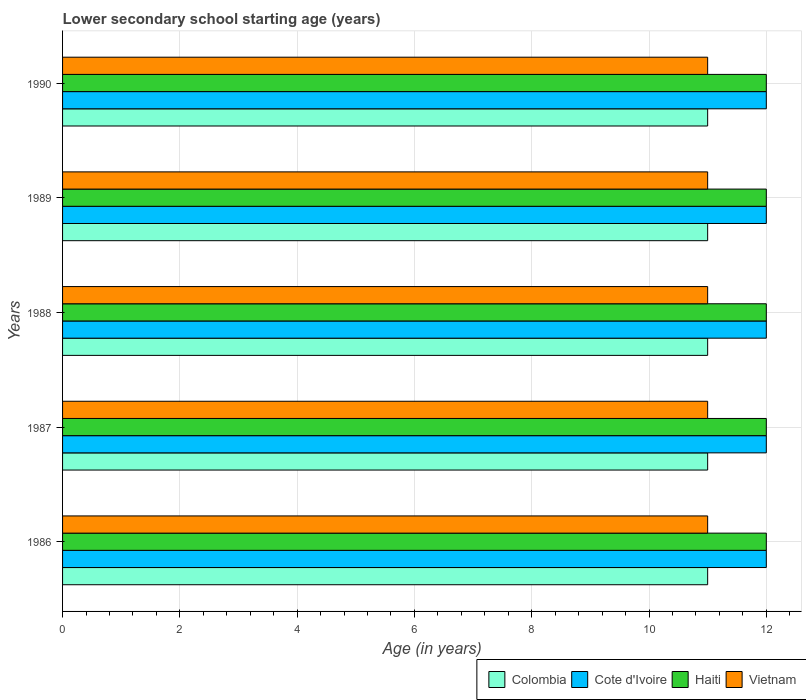How many different coloured bars are there?
Your answer should be compact. 4. How many bars are there on the 3rd tick from the bottom?
Provide a short and direct response. 4. What is the label of the 2nd group of bars from the top?
Make the answer very short. 1989. In how many cases, is the number of bars for a given year not equal to the number of legend labels?
Your response must be concise. 0. What is the lower secondary school starting age of children in Haiti in 1988?
Your response must be concise. 12. Across all years, what is the maximum lower secondary school starting age of children in Colombia?
Provide a succinct answer. 11. Across all years, what is the minimum lower secondary school starting age of children in Haiti?
Your response must be concise. 12. In which year was the lower secondary school starting age of children in Haiti minimum?
Make the answer very short. 1986. What is the total lower secondary school starting age of children in Cote d'Ivoire in the graph?
Offer a terse response. 60. What is the difference between the lower secondary school starting age of children in Cote d'Ivoire in 1990 and the lower secondary school starting age of children in Colombia in 1986?
Provide a short and direct response. 1. In the year 1990, what is the difference between the lower secondary school starting age of children in Cote d'Ivoire and lower secondary school starting age of children in Colombia?
Provide a succinct answer. 1. In how many years, is the lower secondary school starting age of children in Vietnam greater than 4.4 years?
Provide a short and direct response. 5. Is the lower secondary school starting age of children in Haiti in 1986 less than that in 1988?
Your answer should be very brief. No. Is the difference between the lower secondary school starting age of children in Cote d'Ivoire in 1986 and 1990 greater than the difference between the lower secondary school starting age of children in Colombia in 1986 and 1990?
Offer a very short reply. No. What is the difference between the highest and the second highest lower secondary school starting age of children in Cote d'Ivoire?
Ensure brevity in your answer.  0. What is the difference between the highest and the lowest lower secondary school starting age of children in Vietnam?
Offer a terse response. 0. What does the 1st bar from the top in 1990 represents?
Offer a very short reply. Vietnam. What does the 2nd bar from the bottom in 1990 represents?
Offer a very short reply. Cote d'Ivoire. What is the difference between two consecutive major ticks on the X-axis?
Give a very brief answer. 2. Does the graph contain grids?
Make the answer very short. Yes. How many legend labels are there?
Provide a succinct answer. 4. How are the legend labels stacked?
Make the answer very short. Horizontal. What is the title of the graph?
Provide a succinct answer. Lower secondary school starting age (years). What is the label or title of the X-axis?
Give a very brief answer. Age (in years). What is the label or title of the Y-axis?
Provide a short and direct response. Years. What is the Age (in years) of Haiti in 1986?
Provide a succinct answer. 12. What is the Age (in years) in Colombia in 1987?
Offer a terse response. 11. What is the Age (in years) of Cote d'Ivoire in 1987?
Keep it short and to the point. 12. What is the Age (in years) of Vietnam in 1987?
Your answer should be very brief. 11. What is the Age (in years) in Colombia in 1988?
Keep it short and to the point. 11. What is the Age (in years) in Cote d'Ivoire in 1988?
Your answer should be very brief. 12. What is the Age (in years) of Haiti in 1988?
Offer a terse response. 12. What is the Age (in years) of Vietnam in 1988?
Give a very brief answer. 11. What is the Age (in years) of Colombia in 1989?
Make the answer very short. 11. What is the Age (in years) in Cote d'Ivoire in 1989?
Offer a very short reply. 12. What is the Age (in years) in Vietnam in 1989?
Provide a short and direct response. 11. What is the Age (in years) in Cote d'Ivoire in 1990?
Keep it short and to the point. 12. What is the Age (in years) in Vietnam in 1990?
Keep it short and to the point. 11. Across all years, what is the maximum Age (in years) of Colombia?
Provide a succinct answer. 11. Across all years, what is the maximum Age (in years) of Cote d'Ivoire?
Make the answer very short. 12. Across all years, what is the minimum Age (in years) of Colombia?
Offer a very short reply. 11. Across all years, what is the minimum Age (in years) in Cote d'Ivoire?
Keep it short and to the point. 12. Across all years, what is the minimum Age (in years) of Haiti?
Provide a succinct answer. 12. Across all years, what is the minimum Age (in years) of Vietnam?
Keep it short and to the point. 11. What is the total Age (in years) in Colombia in the graph?
Your answer should be very brief. 55. What is the total Age (in years) of Vietnam in the graph?
Make the answer very short. 55. What is the difference between the Age (in years) in Cote d'Ivoire in 1986 and that in 1987?
Offer a terse response. 0. What is the difference between the Age (in years) in Haiti in 1986 and that in 1988?
Give a very brief answer. 0. What is the difference between the Age (in years) in Vietnam in 1986 and that in 1988?
Provide a succinct answer. 0. What is the difference between the Age (in years) in Colombia in 1986 and that in 1989?
Ensure brevity in your answer.  0. What is the difference between the Age (in years) of Cote d'Ivoire in 1986 and that in 1989?
Offer a terse response. 0. What is the difference between the Age (in years) in Colombia in 1986 and that in 1990?
Provide a short and direct response. 0. What is the difference between the Age (in years) of Haiti in 1986 and that in 1990?
Provide a short and direct response. 0. What is the difference between the Age (in years) of Cote d'Ivoire in 1987 and that in 1988?
Offer a terse response. 0. What is the difference between the Age (in years) in Vietnam in 1987 and that in 1988?
Provide a short and direct response. 0. What is the difference between the Age (in years) in Colombia in 1987 and that in 1989?
Give a very brief answer. 0. What is the difference between the Age (in years) of Haiti in 1987 and that in 1990?
Your answer should be compact. 0. What is the difference between the Age (in years) of Haiti in 1988 and that in 1989?
Offer a terse response. 0. What is the difference between the Age (in years) of Colombia in 1988 and that in 1990?
Give a very brief answer. 0. What is the difference between the Age (in years) in Vietnam in 1988 and that in 1990?
Offer a very short reply. 0. What is the difference between the Age (in years) in Vietnam in 1989 and that in 1990?
Keep it short and to the point. 0. What is the difference between the Age (in years) of Colombia in 1986 and the Age (in years) of Cote d'Ivoire in 1987?
Make the answer very short. -1. What is the difference between the Age (in years) of Colombia in 1986 and the Age (in years) of Haiti in 1987?
Make the answer very short. -1. What is the difference between the Age (in years) in Colombia in 1986 and the Age (in years) in Vietnam in 1987?
Make the answer very short. 0. What is the difference between the Age (in years) of Cote d'Ivoire in 1986 and the Age (in years) of Vietnam in 1987?
Offer a very short reply. 1. What is the difference between the Age (in years) of Colombia in 1986 and the Age (in years) of Cote d'Ivoire in 1988?
Your answer should be very brief. -1. What is the difference between the Age (in years) of Colombia in 1986 and the Age (in years) of Vietnam in 1988?
Provide a succinct answer. 0. What is the difference between the Age (in years) of Cote d'Ivoire in 1986 and the Age (in years) of Vietnam in 1988?
Provide a succinct answer. 1. What is the difference between the Age (in years) of Haiti in 1986 and the Age (in years) of Vietnam in 1988?
Provide a short and direct response. 1. What is the difference between the Age (in years) of Colombia in 1986 and the Age (in years) of Haiti in 1989?
Provide a succinct answer. -1. What is the difference between the Age (in years) of Colombia in 1986 and the Age (in years) of Vietnam in 1989?
Give a very brief answer. 0. What is the difference between the Age (in years) of Colombia in 1986 and the Age (in years) of Cote d'Ivoire in 1990?
Your answer should be compact. -1. What is the difference between the Age (in years) in Colombia in 1986 and the Age (in years) in Haiti in 1990?
Provide a succinct answer. -1. What is the difference between the Age (in years) in Haiti in 1986 and the Age (in years) in Vietnam in 1990?
Your answer should be very brief. 1. What is the difference between the Age (in years) of Colombia in 1987 and the Age (in years) of Cote d'Ivoire in 1989?
Your answer should be compact. -1. What is the difference between the Age (in years) of Cote d'Ivoire in 1987 and the Age (in years) of Haiti in 1989?
Offer a terse response. 0. What is the difference between the Age (in years) of Colombia in 1987 and the Age (in years) of Vietnam in 1990?
Give a very brief answer. 0. What is the difference between the Age (in years) in Cote d'Ivoire in 1987 and the Age (in years) in Haiti in 1990?
Provide a short and direct response. 0. What is the difference between the Age (in years) in Colombia in 1988 and the Age (in years) in Cote d'Ivoire in 1989?
Provide a succinct answer. -1. What is the difference between the Age (in years) of Colombia in 1988 and the Age (in years) of Vietnam in 1989?
Offer a very short reply. 0. What is the difference between the Age (in years) of Cote d'Ivoire in 1988 and the Age (in years) of Haiti in 1989?
Make the answer very short. 0. What is the difference between the Age (in years) in Cote d'Ivoire in 1988 and the Age (in years) in Vietnam in 1989?
Provide a succinct answer. 1. What is the difference between the Age (in years) in Haiti in 1988 and the Age (in years) in Vietnam in 1989?
Offer a very short reply. 1. What is the difference between the Age (in years) in Colombia in 1988 and the Age (in years) in Cote d'Ivoire in 1990?
Offer a very short reply. -1. What is the difference between the Age (in years) in Colombia in 1988 and the Age (in years) in Haiti in 1990?
Ensure brevity in your answer.  -1. What is the difference between the Age (in years) of Cote d'Ivoire in 1988 and the Age (in years) of Haiti in 1990?
Your answer should be compact. 0. What is the difference between the Age (in years) in Cote d'Ivoire in 1988 and the Age (in years) in Vietnam in 1990?
Provide a short and direct response. 1. What is the difference between the Age (in years) in Haiti in 1988 and the Age (in years) in Vietnam in 1990?
Offer a very short reply. 1. What is the difference between the Age (in years) in Colombia in 1989 and the Age (in years) in Cote d'Ivoire in 1990?
Give a very brief answer. -1. What is the difference between the Age (in years) in Colombia in 1989 and the Age (in years) in Vietnam in 1990?
Your answer should be very brief. 0. What is the difference between the Age (in years) in Cote d'Ivoire in 1989 and the Age (in years) in Vietnam in 1990?
Offer a terse response. 1. What is the difference between the Age (in years) in Haiti in 1989 and the Age (in years) in Vietnam in 1990?
Your answer should be very brief. 1. What is the average Age (in years) of Cote d'Ivoire per year?
Provide a short and direct response. 12. What is the average Age (in years) of Haiti per year?
Make the answer very short. 12. In the year 1986, what is the difference between the Age (in years) in Colombia and Age (in years) in Haiti?
Give a very brief answer. -1. In the year 1986, what is the difference between the Age (in years) of Colombia and Age (in years) of Vietnam?
Your response must be concise. 0. In the year 1987, what is the difference between the Age (in years) of Colombia and Age (in years) of Haiti?
Keep it short and to the point. -1. In the year 1987, what is the difference between the Age (in years) of Colombia and Age (in years) of Vietnam?
Provide a succinct answer. 0. In the year 1987, what is the difference between the Age (in years) of Haiti and Age (in years) of Vietnam?
Provide a short and direct response. 1. In the year 1988, what is the difference between the Age (in years) in Cote d'Ivoire and Age (in years) in Vietnam?
Provide a succinct answer. 1. In the year 1989, what is the difference between the Age (in years) in Colombia and Age (in years) in Cote d'Ivoire?
Offer a terse response. -1. In the year 1989, what is the difference between the Age (in years) of Colombia and Age (in years) of Haiti?
Ensure brevity in your answer.  -1. In the year 1989, what is the difference between the Age (in years) in Cote d'Ivoire and Age (in years) in Haiti?
Give a very brief answer. 0. In the year 1989, what is the difference between the Age (in years) of Haiti and Age (in years) of Vietnam?
Offer a terse response. 1. In the year 1990, what is the difference between the Age (in years) of Colombia and Age (in years) of Haiti?
Provide a short and direct response. -1. In the year 1990, what is the difference between the Age (in years) in Colombia and Age (in years) in Vietnam?
Offer a very short reply. 0. In the year 1990, what is the difference between the Age (in years) in Cote d'Ivoire and Age (in years) in Haiti?
Offer a very short reply. 0. In the year 1990, what is the difference between the Age (in years) of Cote d'Ivoire and Age (in years) of Vietnam?
Your response must be concise. 1. In the year 1990, what is the difference between the Age (in years) in Haiti and Age (in years) in Vietnam?
Your answer should be compact. 1. What is the ratio of the Age (in years) in Haiti in 1986 to that in 1987?
Your answer should be very brief. 1. What is the ratio of the Age (in years) in Vietnam in 1986 to that in 1987?
Offer a terse response. 1. What is the ratio of the Age (in years) of Colombia in 1986 to that in 1988?
Keep it short and to the point. 1. What is the ratio of the Age (in years) in Cote d'Ivoire in 1986 to that in 1988?
Make the answer very short. 1. What is the ratio of the Age (in years) of Cote d'Ivoire in 1986 to that in 1989?
Give a very brief answer. 1. What is the ratio of the Age (in years) of Vietnam in 1986 to that in 1989?
Offer a terse response. 1. What is the ratio of the Age (in years) in Colombia in 1986 to that in 1990?
Provide a succinct answer. 1. What is the ratio of the Age (in years) in Cote d'Ivoire in 1986 to that in 1990?
Provide a succinct answer. 1. What is the ratio of the Age (in years) in Haiti in 1986 to that in 1990?
Offer a terse response. 1. What is the ratio of the Age (in years) in Vietnam in 1986 to that in 1990?
Provide a short and direct response. 1. What is the ratio of the Age (in years) in Haiti in 1987 to that in 1988?
Provide a short and direct response. 1. What is the ratio of the Age (in years) of Vietnam in 1987 to that in 1989?
Your response must be concise. 1. What is the ratio of the Age (in years) in Colombia in 1987 to that in 1990?
Ensure brevity in your answer.  1. What is the ratio of the Age (in years) in Cote d'Ivoire in 1988 to that in 1989?
Give a very brief answer. 1. What is the ratio of the Age (in years) in Haiti in 1988 to that in 1989?
Offer a very short reply. 1. What is the ratio of the Age (in years) in Colombia in 1988 to that in 1990?
Offer a very short reply. 1. What is the ratio of the Age (in years) in Haiti in 1988 to that in 1990?
Offer a very short reply. 1. What is the ratio of the Age (in years) of Haiti in 1989 to that in 1990?
Provide a succinct answer. 1. What is the ratio of the Age (in years) of Vietnam in 1989 to that in 1990?
Your answer should be compact. 1. What is the difference between the highest and the second highest Age (in years) of Haiti?
Provide a short and direct response. 0. What is the difference between the highest and the second highest Age (in years) in Vietnam?
Your response must be concise. 0. What is the difference between the highest and the lowest Age (in years) of Colombia?
Offer a very short reply. 0. 